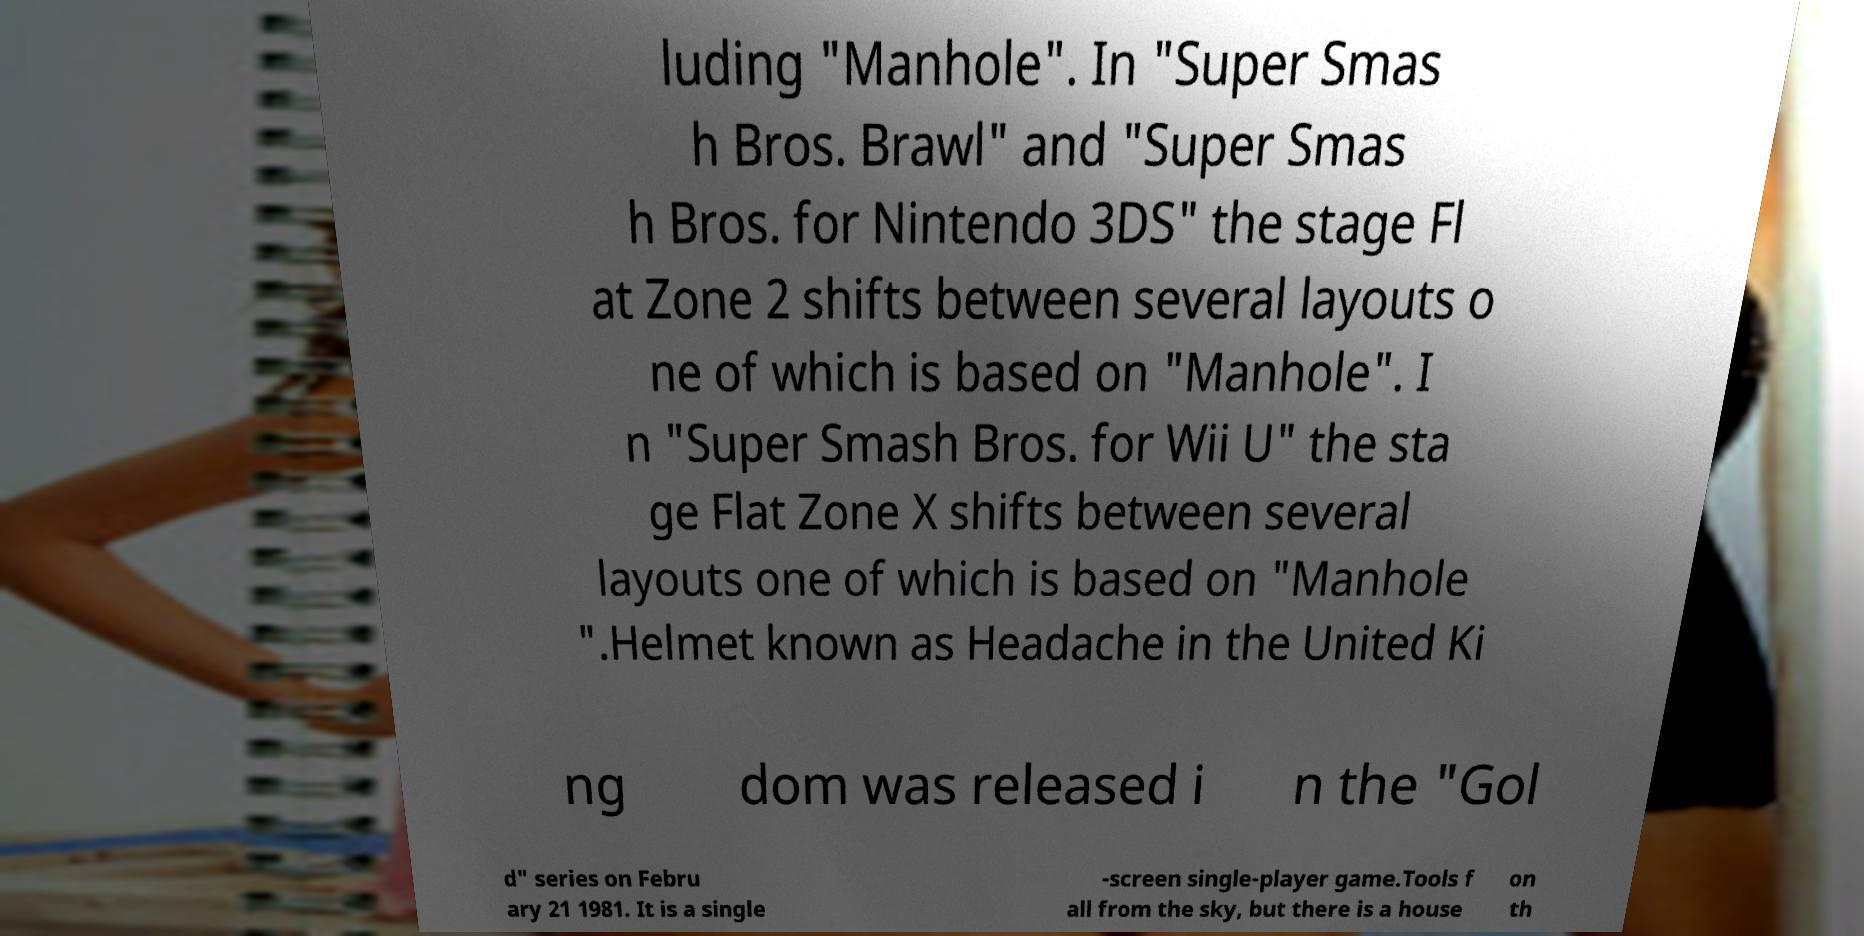I need the written content from this picture converted into text. Can you do that? luding "Manhole". In "Super Smas h Bros. Brawl" and "Super Smas h Bros. for Nintendo 3DS" the stage Fl at Zone 2 shifts between several layouts o ne of which is based on "Manhole". I n "Super Smash Bros. for Wii U" the sta ge Flat Zone X shifts between several layouts one of which is based on "Manhole ".Helmet known as Headache in the United Ki ng dom was released i n the "Gol d" series on Febru ary 21 1981. It is a single -screen single-player game.Tools f all from the sky, but there is a house on th 